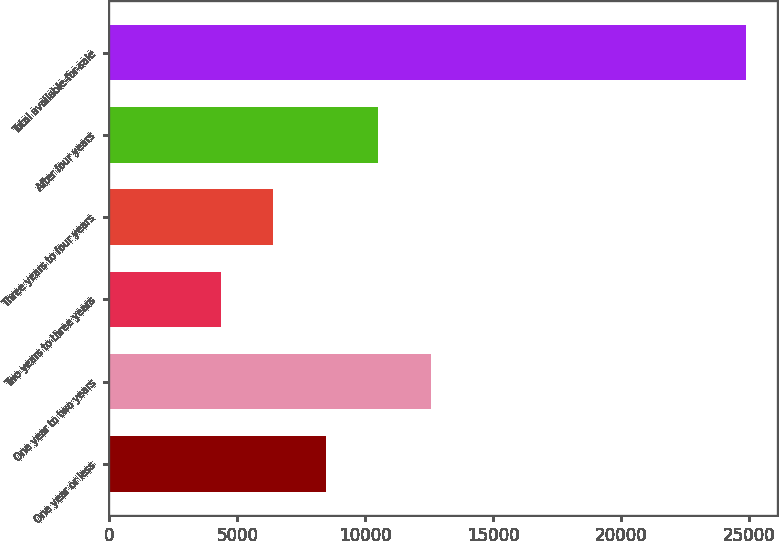Convert chart to OTSL. <chart><loc_0><loc_0><loc_500><loc_500><bar_chart><fcel>One year or less<fcel>One year to two years<fcel>Two years to three years<fcel>Three years to four years<fcel>After four years<fcel>Total available-for-sale<nl><fcel>8461.9<fcel>12561.2<fcel>4362.6<fcel>6412.25<fcel>10511.5<fcel>24859.1<nl></chart> 